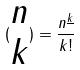Convert formula to latex. <formula><loc_0><loc_0><loc_500><loc_500>( \begin{matrix} n \\ k \end{matrix} ) = \frac { n ^ { \underline { k } } } { k ! }</formula> 